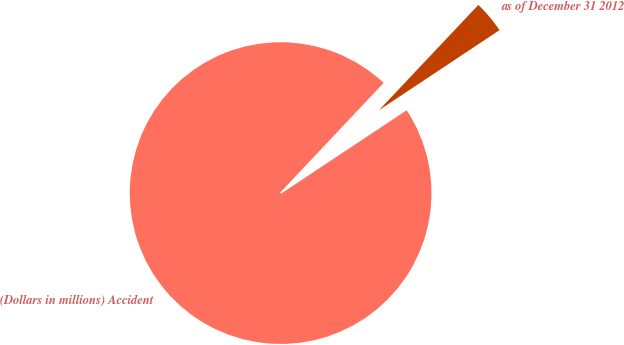<chart> <loc_0><loc_0><loc_500><loc_500><pie_chart><fcel>(Dollars in millions) Accident<fcel>as of December 31 2012<nl><fcel>96.37%<fcel>3.63%<nl></chart> 